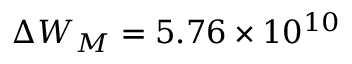Convert formula to latex. <formula><loc_0><loc_0><loc_500><loc_500>\Delta W _ { M } = 5 . 7 6 \times 1 0 ^ { 1 0 }</formula> 